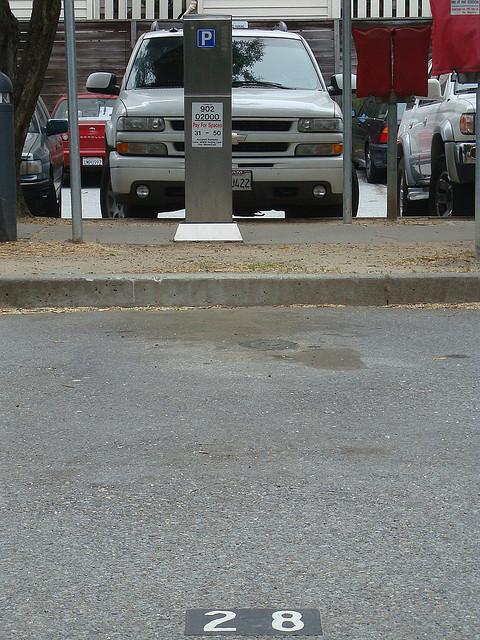Is there a stuffed animal in the photo?
Write a very short answer. No. Why would someone leave this toaster on the sidewalk?
Answer briefly. Broken. How many motorcycles do you see?
Concise answer only. 0. What are the colors most prominently represented?
Keep it brief. Gray. Is there a red car in this scene?
Short answer required. Yes. What number is on the sign?
Quick response, please. 28. Are the two vehicles the same make?
Quick response, please. No. Is there a place on the meter or credit card payments?
Be succinct. No. What kind of vehicle is parked in the background?
Write a very short answer. Truck. Is the ground damp?
Short answer required. No. What model is the white car?
Keep it brief. Ford. What color SUV is in the back?
Write a very short answer. White. What color is the license plate?
Quick response, please. White. Is it sunny out?
Quick response, please. No. How many cars are in the photo?
Short answer required. 5. What is in the image that can be used to pack items?
Quick response, please. Truck. How many cars are in the image?
Short answer required. 5. What is the sidewalk made from?
Give a very brief answer. Concrete. Is the street cracked?
Concise answer only. No. How many vehicles do you see?
Be succinct. 5. What does the blue sign mean?
Be succinct. Parking. Is the ground clean?
Quick response, please. No. 